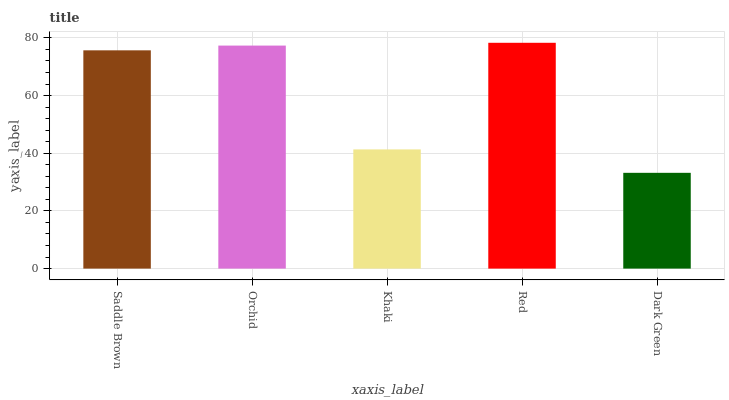Is Orchid the minimum?
Answer yes or no. No. Is Orchid the maximum?
Answer yes or no. No. Is Orchid greater than Saddle Brown?
Answer yes or no. Yes. Is Saddle Brown less than Orchid?
Answer yes or no. Yes. Is Saddle Brown greater than Orchid?
Answer yes or no. No. Is Orchid less than Saddle Brown?
Answer yes or no. No. Is Saddle Brown the high median?
Answer yes or no. Yes. Is Saddle Brown the low median?
Answer yes or no. Yes. Is Orchid the high median?
Answer yes or no. No. Is Red the low median?
Answer yes or no. No. 